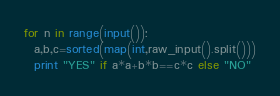Convert code to text. <code><loc_0><loc_0><loc_500><loc_500><_Python_>for n in range(input()):
  a,b,c=sorted(map(int,raw_input().split()))
  print "YES" if a*a+b*b==c*c else "NO"</code> 